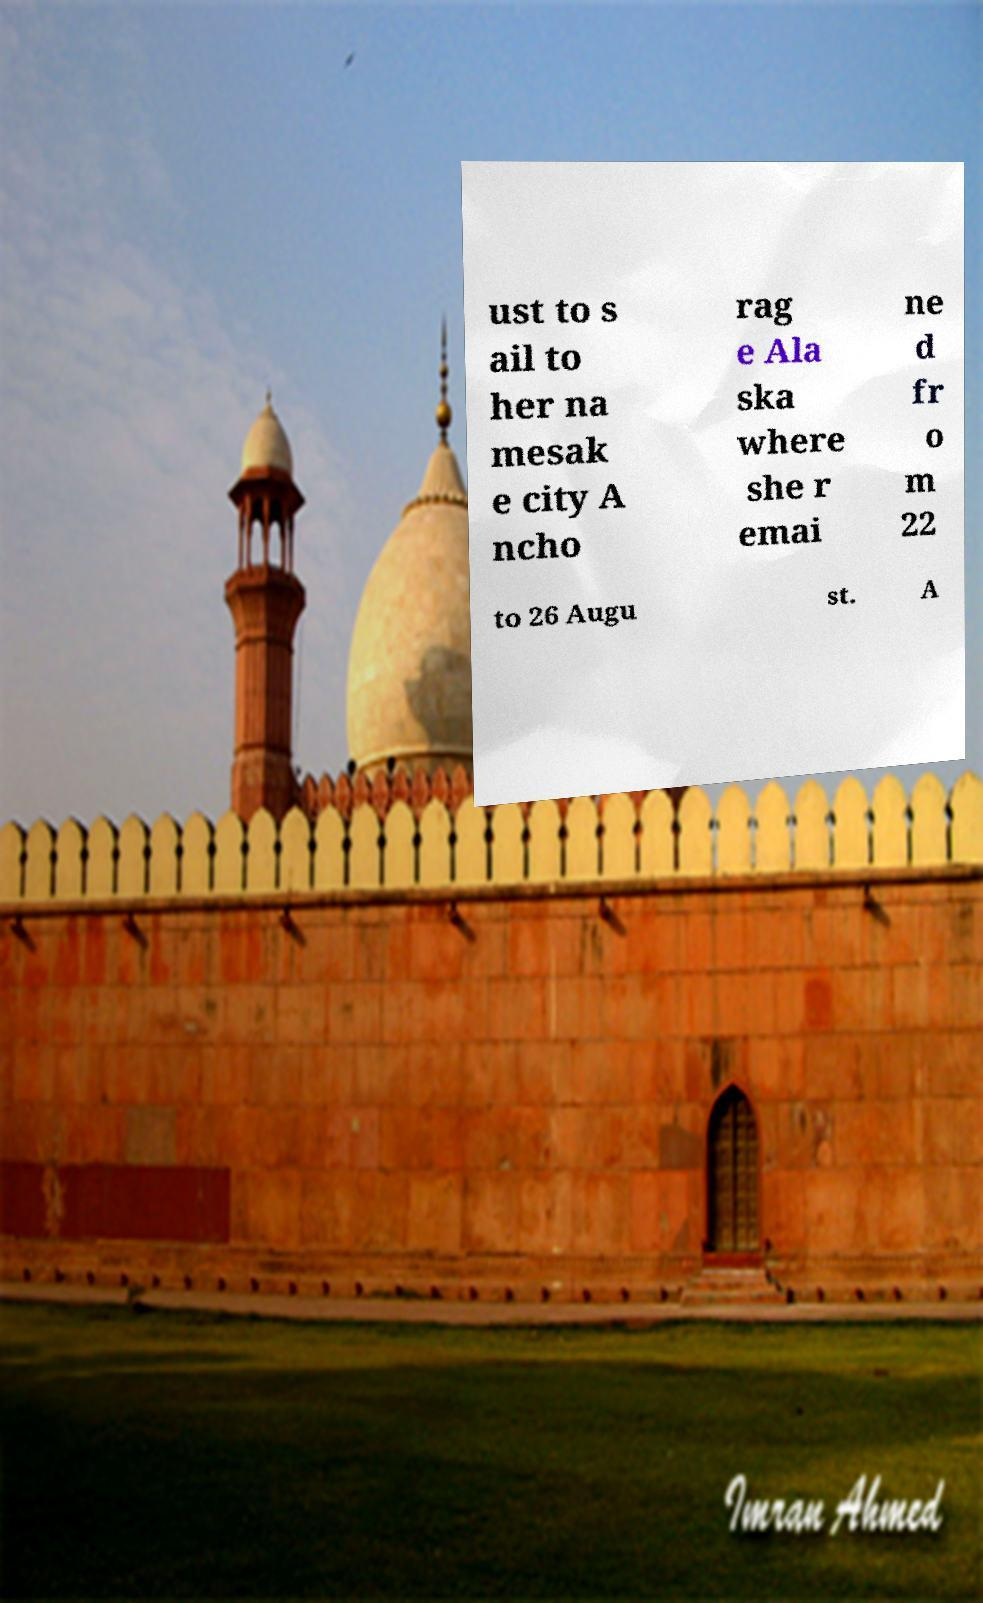Please identify and transcribe the text found in this image. ust to s ail to her na mesak e city A ncho rag e Ala ska where she r emai ne d fr o m 22 to 26 Augu st. A 